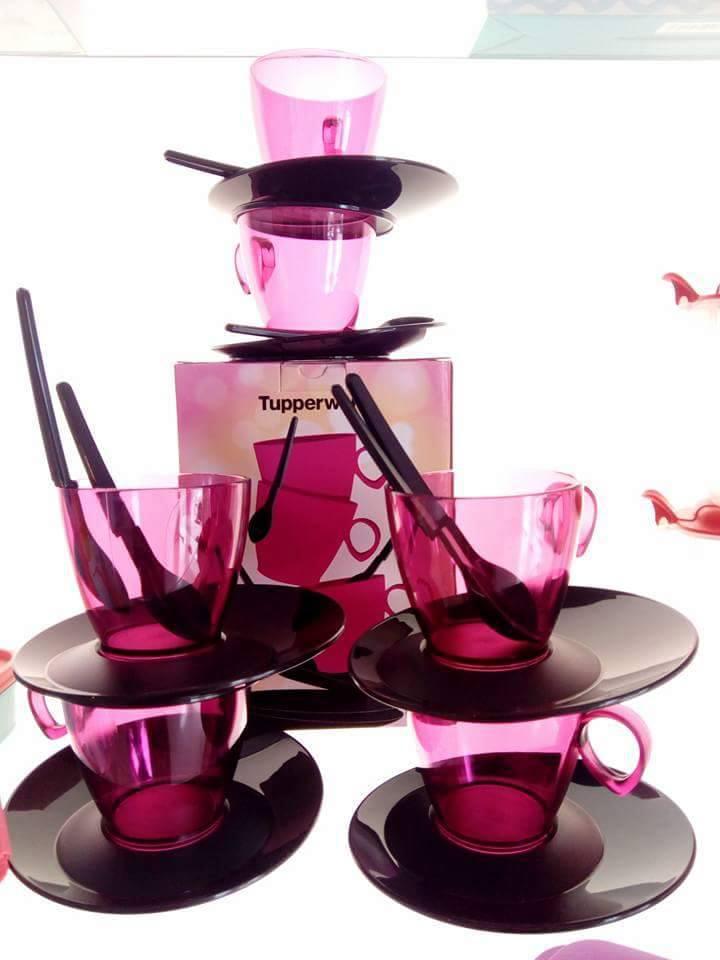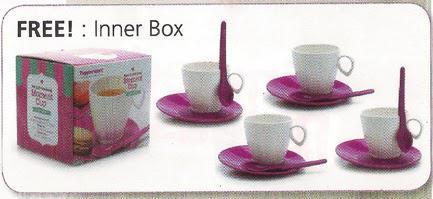The first image is the image on the left, the second image is the image on the right. Evaluate the accuracy of this statement regarding the images: "Pink transparent cups are on the left image.". Is it true? Answer yes or no. Yes. 